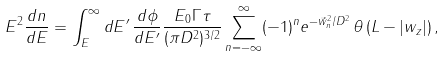Convert formula to latex. <formula><loc_0><loc_0><loc_500><loc_500>E ^ { 2 } \frac { d n } { d E } = \int _ { E } ^ { \infty } d E ^ { \prime } \, \frac { d \phi } { d E ^ { \prime } } \frac { E _ { 0 } \Gamma \tau } { ( \pi D ^ { 2 } ) ^ { 3 / 2 } } \sum _ { n = - \infty } ^ { \infty } ( - 1 ) ^ { n } e ^ { - \vec { w } _ { n } ^ { 2 } / D ^ { 2 } } \, \theta \left ( L - | w _ { z } | \right ) ,</formula> 